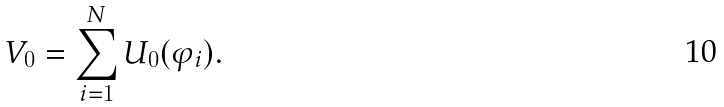Convert formula to latex. <formula><loc_0><loc_0><loc_500><loc_500>V _ { 0 } = \sum _ { i = 1 } ^ { N } U _ { 0 } ( \varphi _ { i } ) .</formula> 